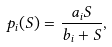<formula> <loc_0><loc_0><loc_500><loc_500>p _ { i } ( S ) = \frac { a _ { i } S } { b _ { i } + S } ,</formula> 